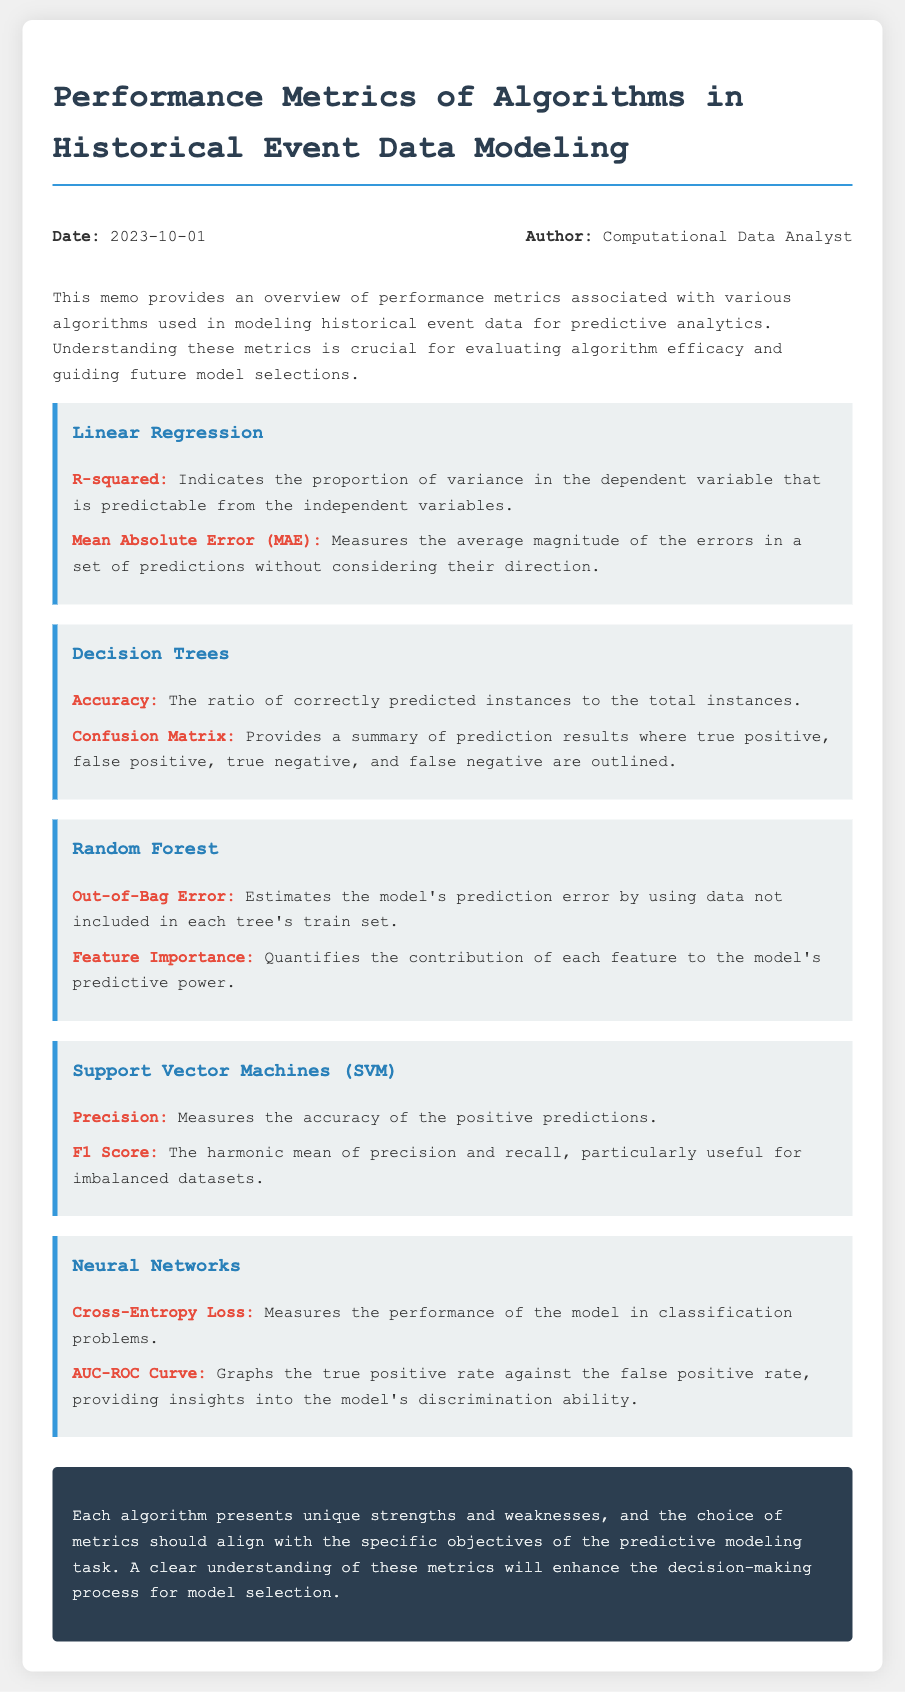What is the date of the memo? The date is mentioned in the header of the memo.
Answer: 2023-10-01 Who is the author of the memo? The author is listed in the header along with the date.
Answer: Computational Data Analyst What metric indicates the proportion of variance that is predictable in Linear Regression? This information is provided under the Linear Regression algorithm section.
Answer: R-squared Which algorithm uses Cross-Entropy Loss as a performance metric? This information is derived from the description of the Neural Networks section.
Answer: Neural Networks What does the Confusion Matrix summarize in Decision Trees? The function of the Confusion Matrix is outlined in the Decision Trees section.
Answer: Prediction results What is the main focus of the conclusion in the memo? The memo's conclusion discusses the importance of understanding metrics for model selection.
Answer: Model selection What metric is used to estimate the prediction error in Random Forest? The Random Forest section specifically lists this metric.
Answer: Out-of-Bag Error Which metric measures accuracy in positive predictions for Support Vector Machines? This metric is detailed under the Support Vector Machines section.
Answer: Precision 